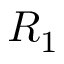<formula> <loc_0><loc_0><loc_500><loc_500>R _ { 1 }</formula> 